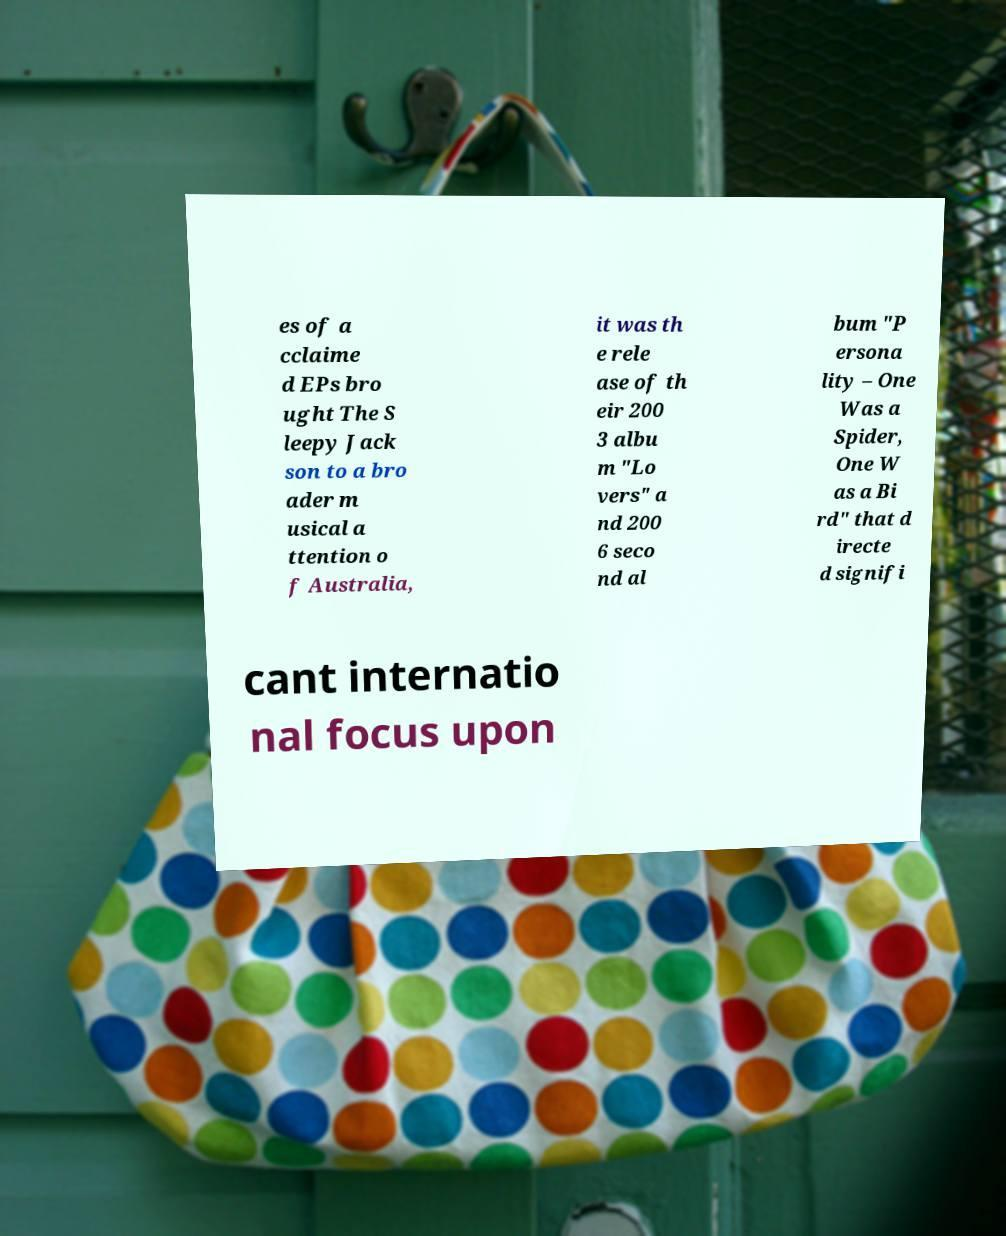For documentation purposes, I need the text within this image transcribed. Could you provide that? es of a cclaime d EPs bro ught The S leepy Jack son to a bro ader m usical a ttention o f Australia, it was th e rele ase of th eir 200 3 albu m "Lo vers" a nd 200 6 seco nd al bum "P ersona lity – One Was a Spider, One W as a Bi rd" that d irecte d signifi cant internatio nal focus upon 